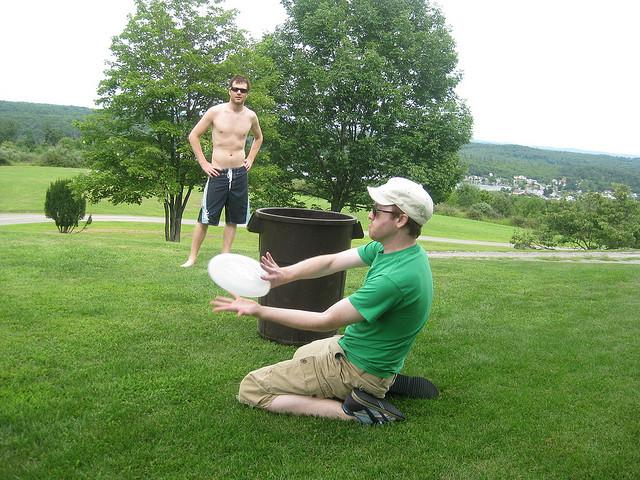What is the man wearing a hat doing? Please explain your reasoning. catching frisbee. The man with the hat is holding out his hands to catch a frisbee. 